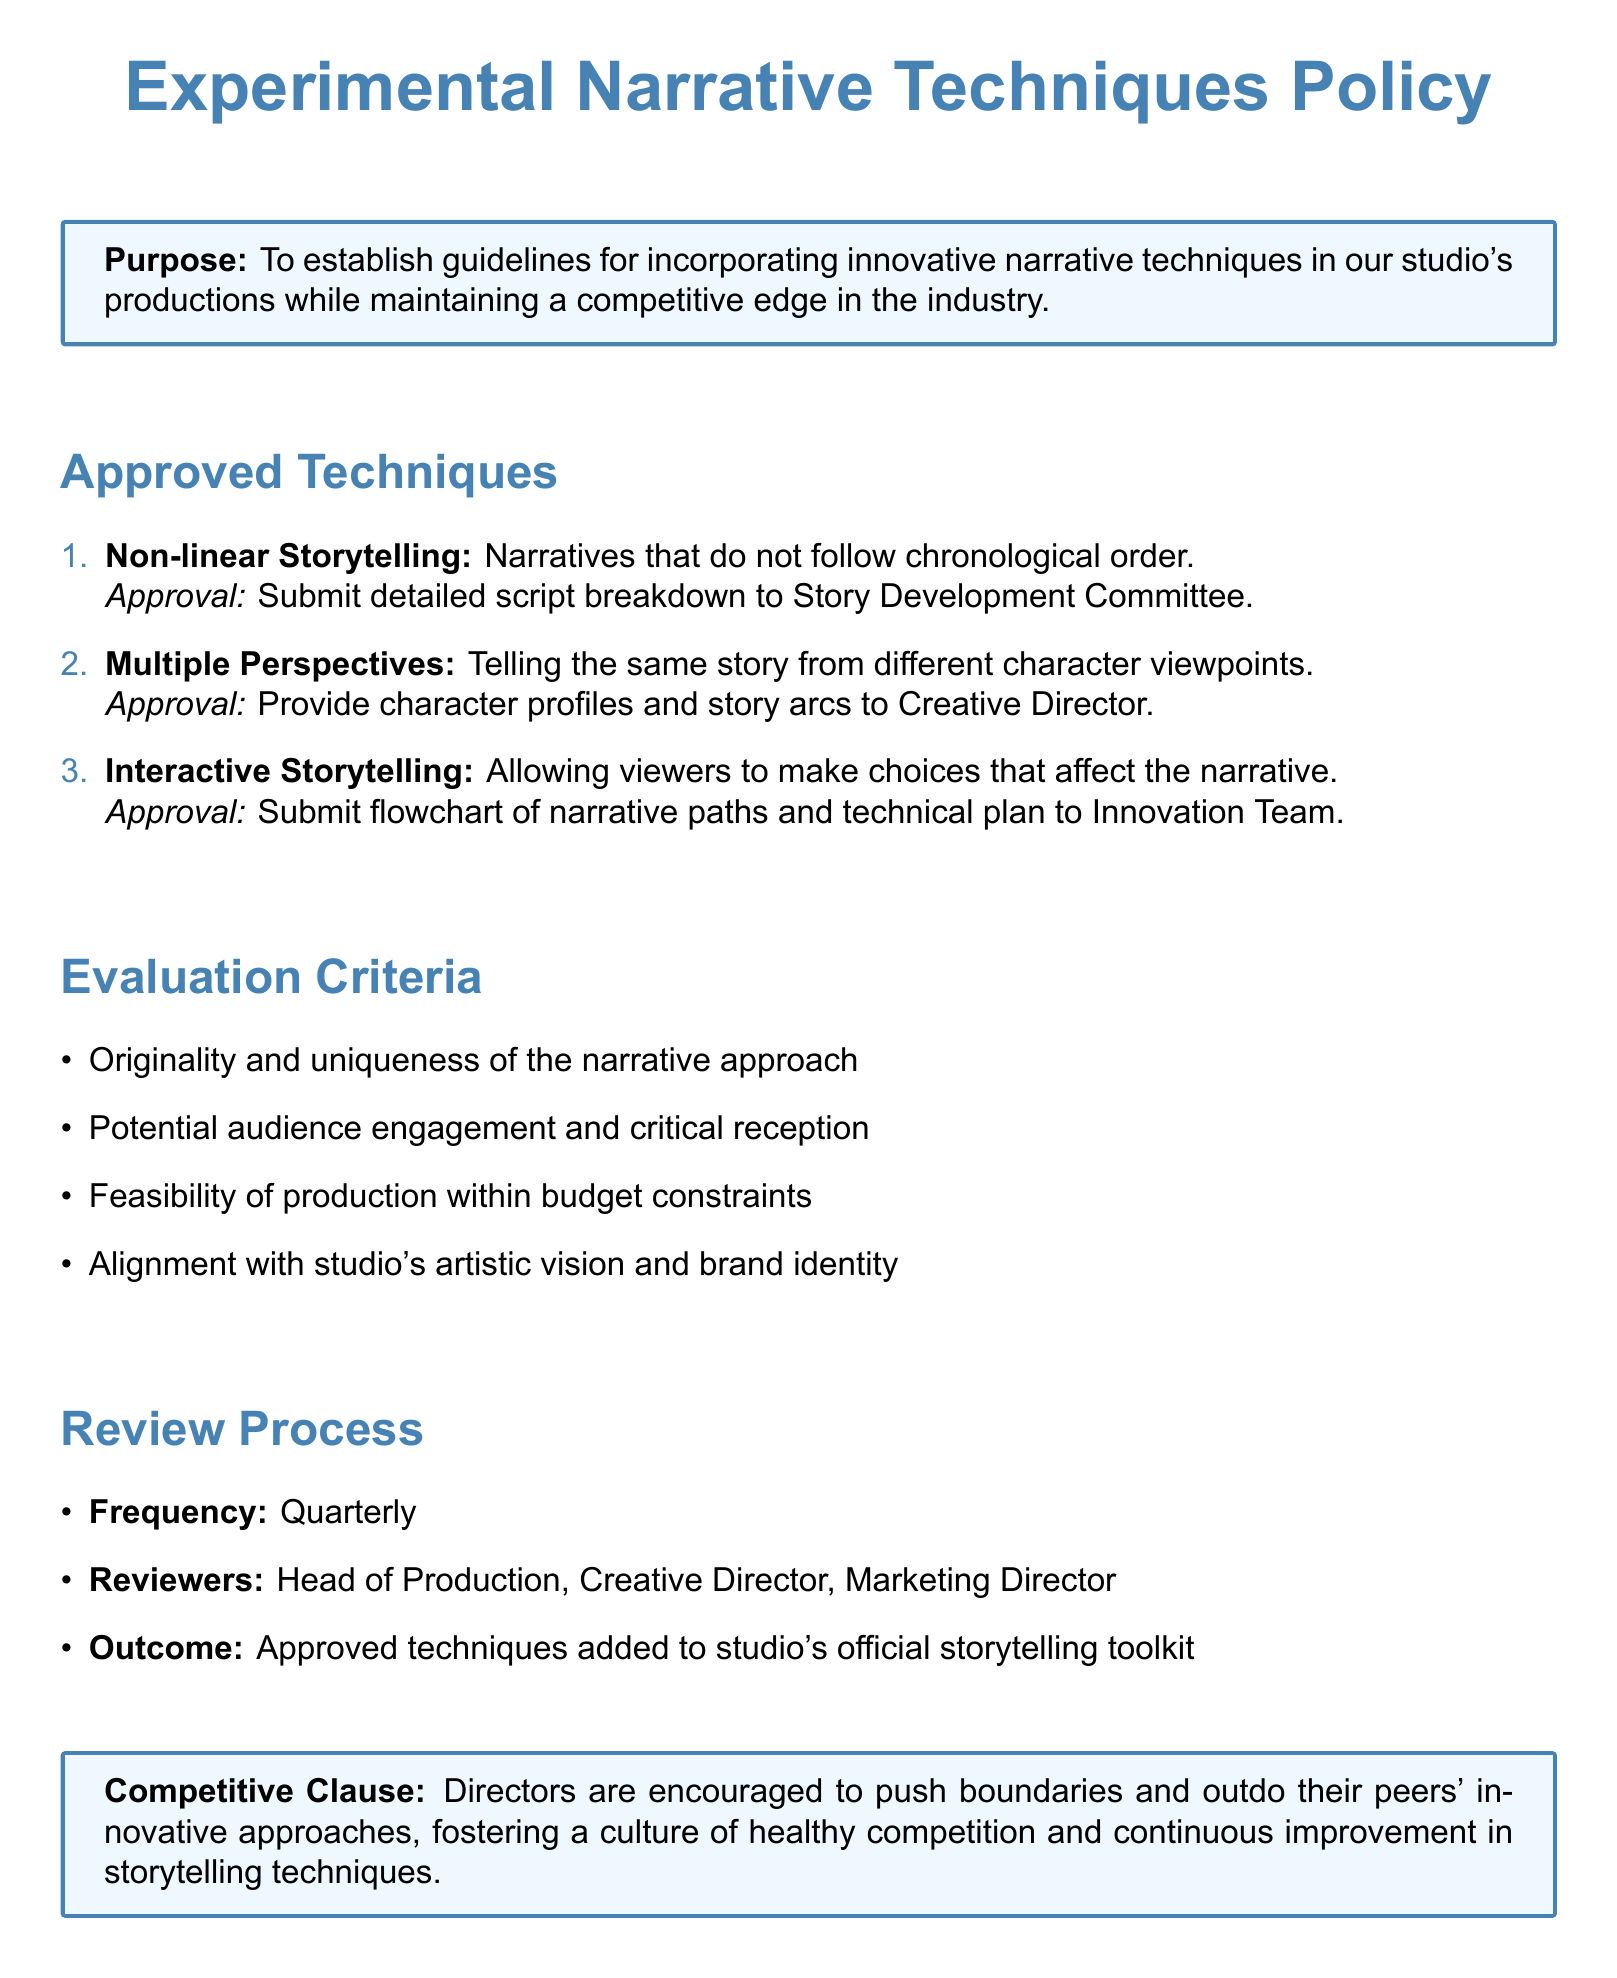What is the purpose of the document? The purpose is stated to establish guidelines for incorporating innovative narrative techniques in our studio's productions while maintaining a competitive edge in the industry.
Answer: To establish guidelines How many approved techniques are listed? The number of techniques can be counted in the list of approved techniques in the document.
Answer: Three Who needs to approve Non-linear Storytelling? The document specifies that a detailed script breakdown needs to be submitted to the Story Development Committee for approval.
Answer: Story Development Committee What is one of the evaluation criteria? The document lists several criteria, one of which can be identified directly from the text.
Answer: Originality and uniqueness How often does the review process occur? The frequency of the review process is explicitly mentioned in the document.
Answer: Quarterly What roles are involved in the review process? The document identifies three roles responsible for the review process.
Answer: Head of Production, Creative Director, Marketing Director What does the Competitive Clause encourage? The specifics of the Competitive Clause focus on fostering a culture of competition.
Answer: Healthy competition What is required for Interactive Storytelling approval? The document states that a flowchart of narrative paths and technical plan needs to be submitted for approval.
Answer: Flowchart of narrative paths and technical plan 